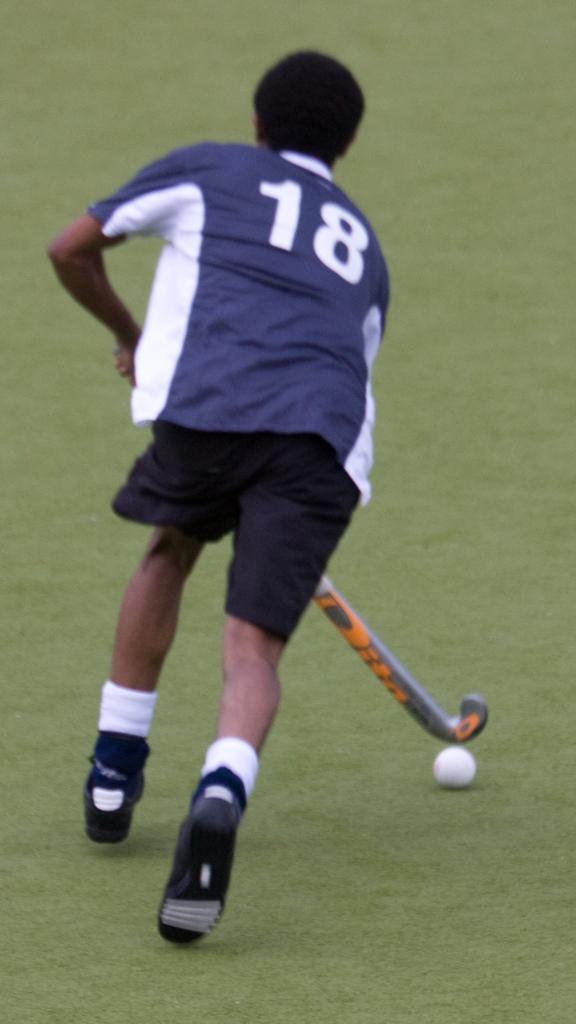Can you describe this image briefly? In this image I can see a person is playing a hockey on the ground and a ball. This image is taken may be during a day. 